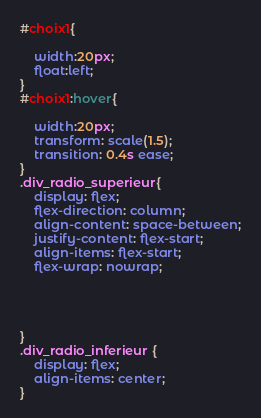<code> <loc_0><loc_0><loc_500><loc_500><_CSS_>

#choix1{

    width:20px;
    float:left;
}
#choix1:hover{

    width:20px;
    transform: scale(1.5);
    transition: 0.4s ease;
}
.div_radio_superieur{
    display: flex;
    flex-direction: column;
    align-content: space-between;
    justify-content: flex-start;
    align-items: flex-start;
    flex-wrap: nowrap;
    
    


}
.div_radio_inferieur {
    display: flex;
    align-items: center;
}</code> 